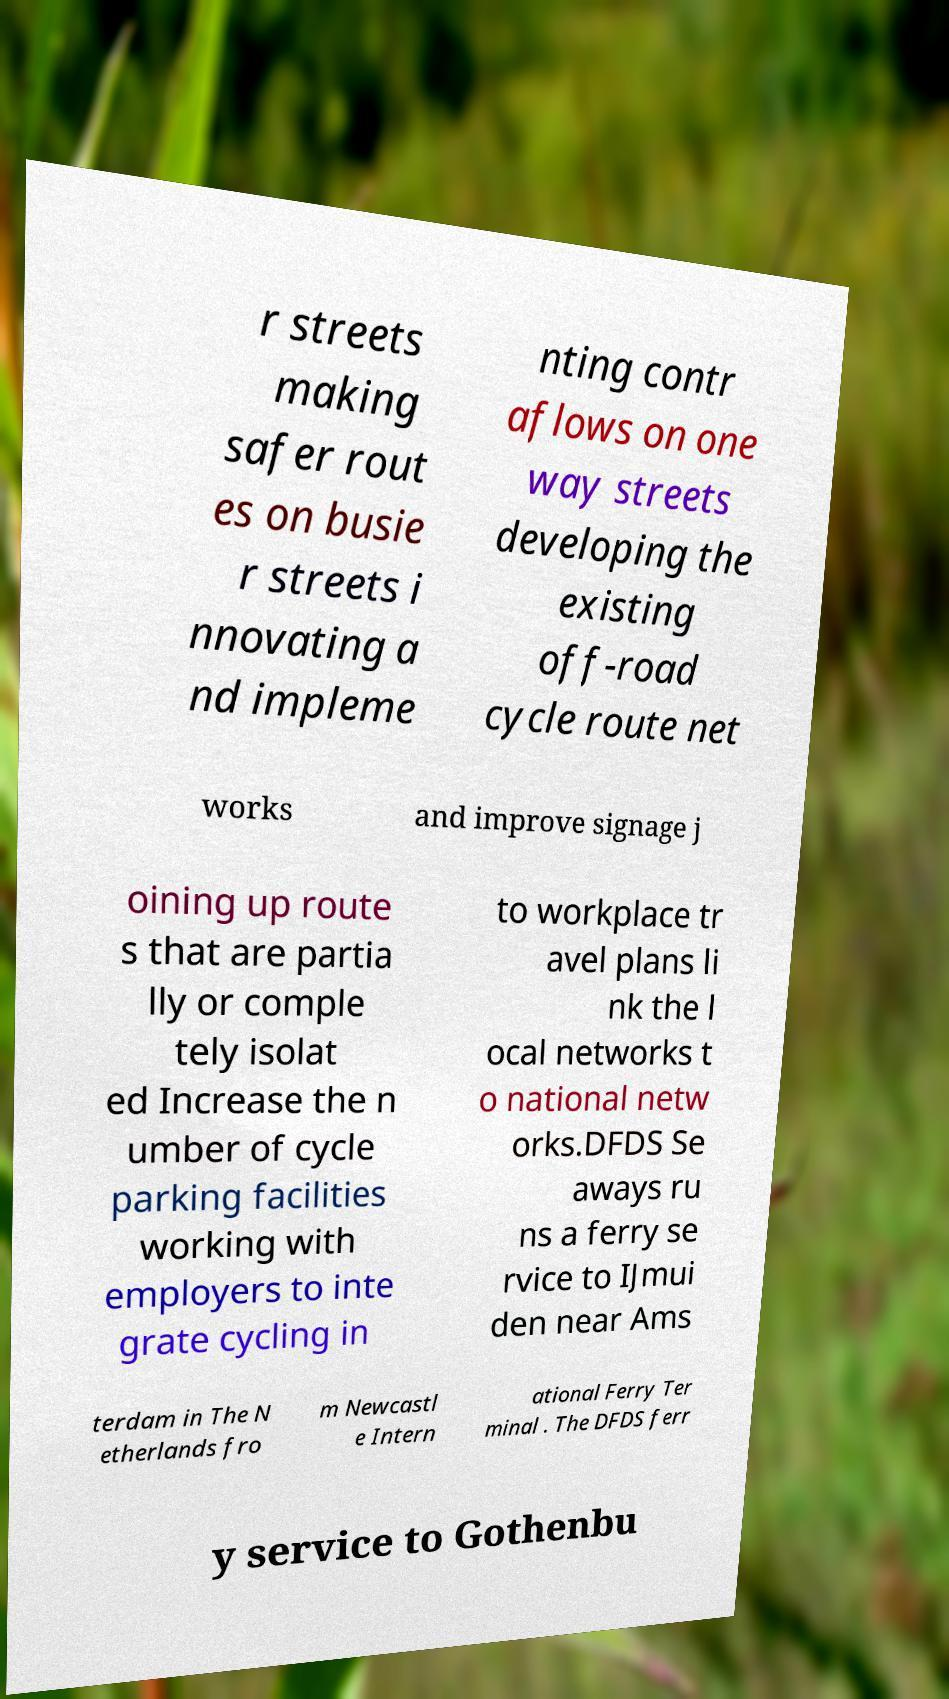For documentation purposes, I need the text within this image transcribed. Could you provide that? r streets making safer rout es on busie r streets i nnovating a nd impleme nting contr aflows on one way streets developing the existing off-road cycle route net works and improve signage j oining up route s that are partia lly or comple tely isolat ed Increase the n umber of cycle parking facilities working with employers to inte grate cycling in to workplace tr avel plans li nk the l ocal networks t o national netw orks.DFDS Se aways ru ns a ferry se rvice to IJmui den near Ams terdam in The N etherlands fro m Newcastl e Intern ational Ferry Ter minal . The DFDS ferr y service to Gothenbu 